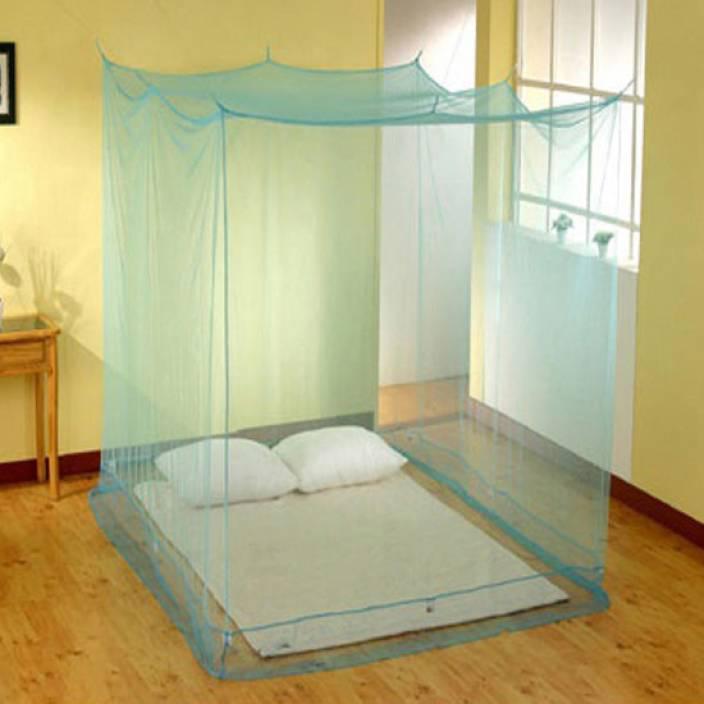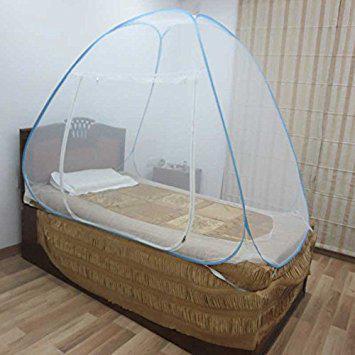The first image is the image on the left, the second image is the image on the right. Analyze the images presented: Is the assertion "One canopy is square shaped." valid? Answer yes or no. Yes. 